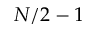Convert formula to latex. <formula><loc_0><loc_0><loc_500><loc_500>N / 2 - 1</formula> 